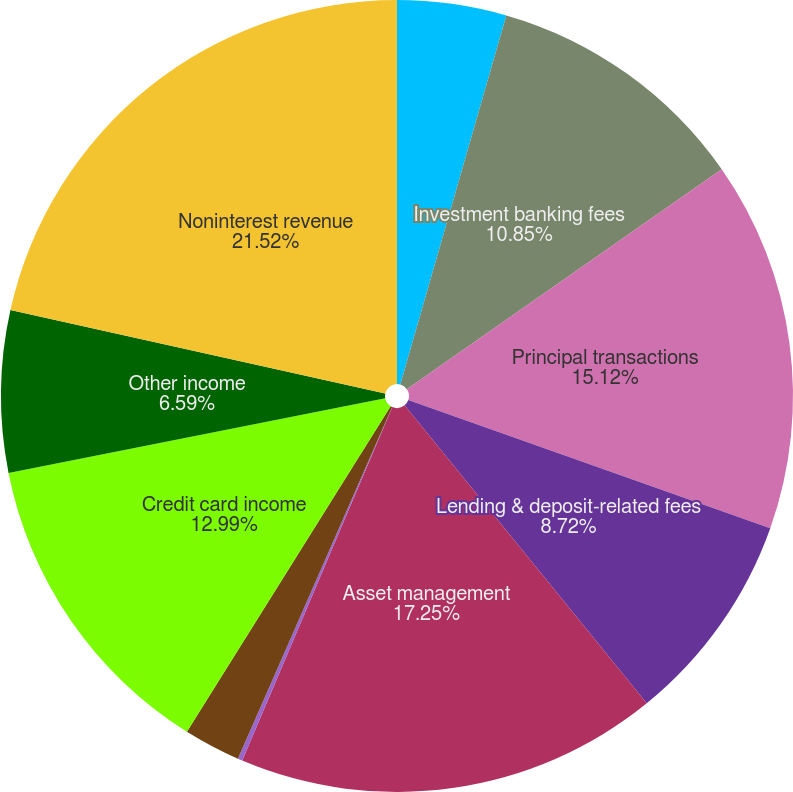<chart> <loc_0><loc_0><loc_500><loc_500><pie_chart><fcel>Year ended December 31 (in<fcel>Investment banking fees<fcel>Principal transactions<fcel>Lending & deposit-related fees<fcel>Asset management<fcel>Securities gains (losses)<fcel>Mortgage fees and related<fcel>Credit card income<fcel>Other income<fcel>Noninterest revenue<nl><fcel>4.45%<fcel>10.85%<fcel>15.12%<fcel>8.72%<fcel>17.25%<fcel>0.19%<fcel>2.32%<fcel>12.99%<fcel>6.59%<fcel>21.52%<nl></chart> 